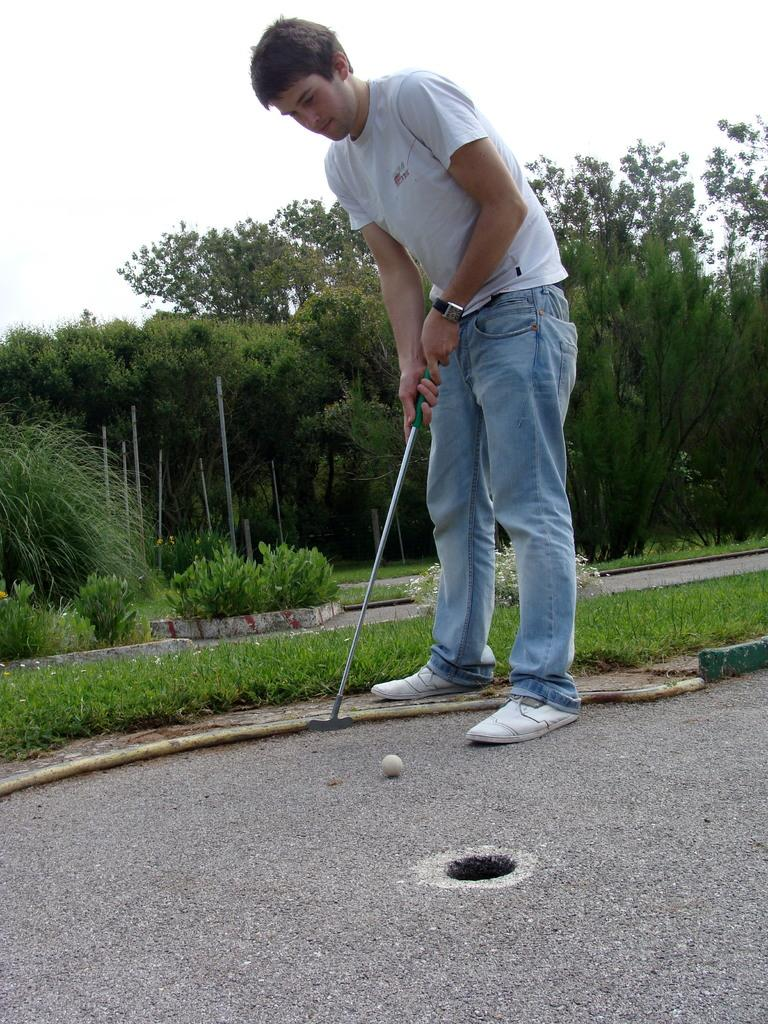What activity is the person in the image engaged in? The person is playing hockey in the image. What type of surface is visible in the image? There is a road and grass in the image. What type of vegetation is present in the image? There are trees in the image. What can be seen in the sky in the image? The sky is visible in the image. What type of bell can be heard in the image? There is no bell present or audible in the image. 